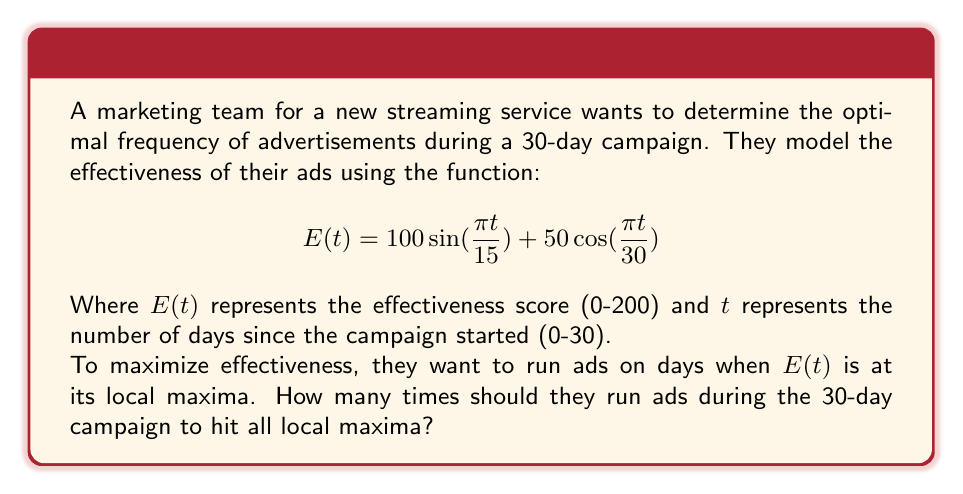Help me with this question. To solve this problem, we need to find the local maxima of the given function within the domain [0, 30]. Let's approach this step-by-step:

1) First, we need to find the derivative of $E(t)$:

   $$E'(t) = \frac{100\pi}{15}\cos(\frac{\pi t}{15}) - \frac{50\pi}{30}\sin(\frac{\pi t}{30})$$

2) To find local maxima, we set $E'(t) = 0$:

   $$\frac{100\pi}{15}\cos(\frac{\pi t}{15}) - \frac{50\pi}{30}\sin(\frac{\pi t}{30}) = 0$$

3) This equation is complex to solve analytically. However, we can observe that the function is a sum of two periodic functions:

   - $100\sin(\frac{\pi t}{15})$ has a period of 30 days
   - $50\cos(\frac{\pi t}{30})$ has a period of 60 days

4) The overall function will repeat every least common multiple of 30 and 60, which is 60 days. This means in our 30-day campaign, we're seeing exactly half of the full cycle.

5) In a full 60-day cycle, a sum of sine and cosine functions like this will typically have two maxima and two minima.

6) Since we're only looking at half of the full cycle (30 days), we can expect to see one maximum and one minimum within our campaign period.

7) Additionally, the endpoints (day 0 and day 30) could also be local maxima.

Therefore, we can conclude that there will be at most 3 local maxima: one at the start of the campaign (day 0), one at the end (day 30), and one somewhere in between.

To verify this, we could plot the function or use numerical methods to find the exact days of the maxima, but for the purposes of this question, knowing the number of maxima is sufficient.
Answer: The marketing team should run ads 3 times during the 30-day campaign to hit all local maxima of the effectiveness function. 